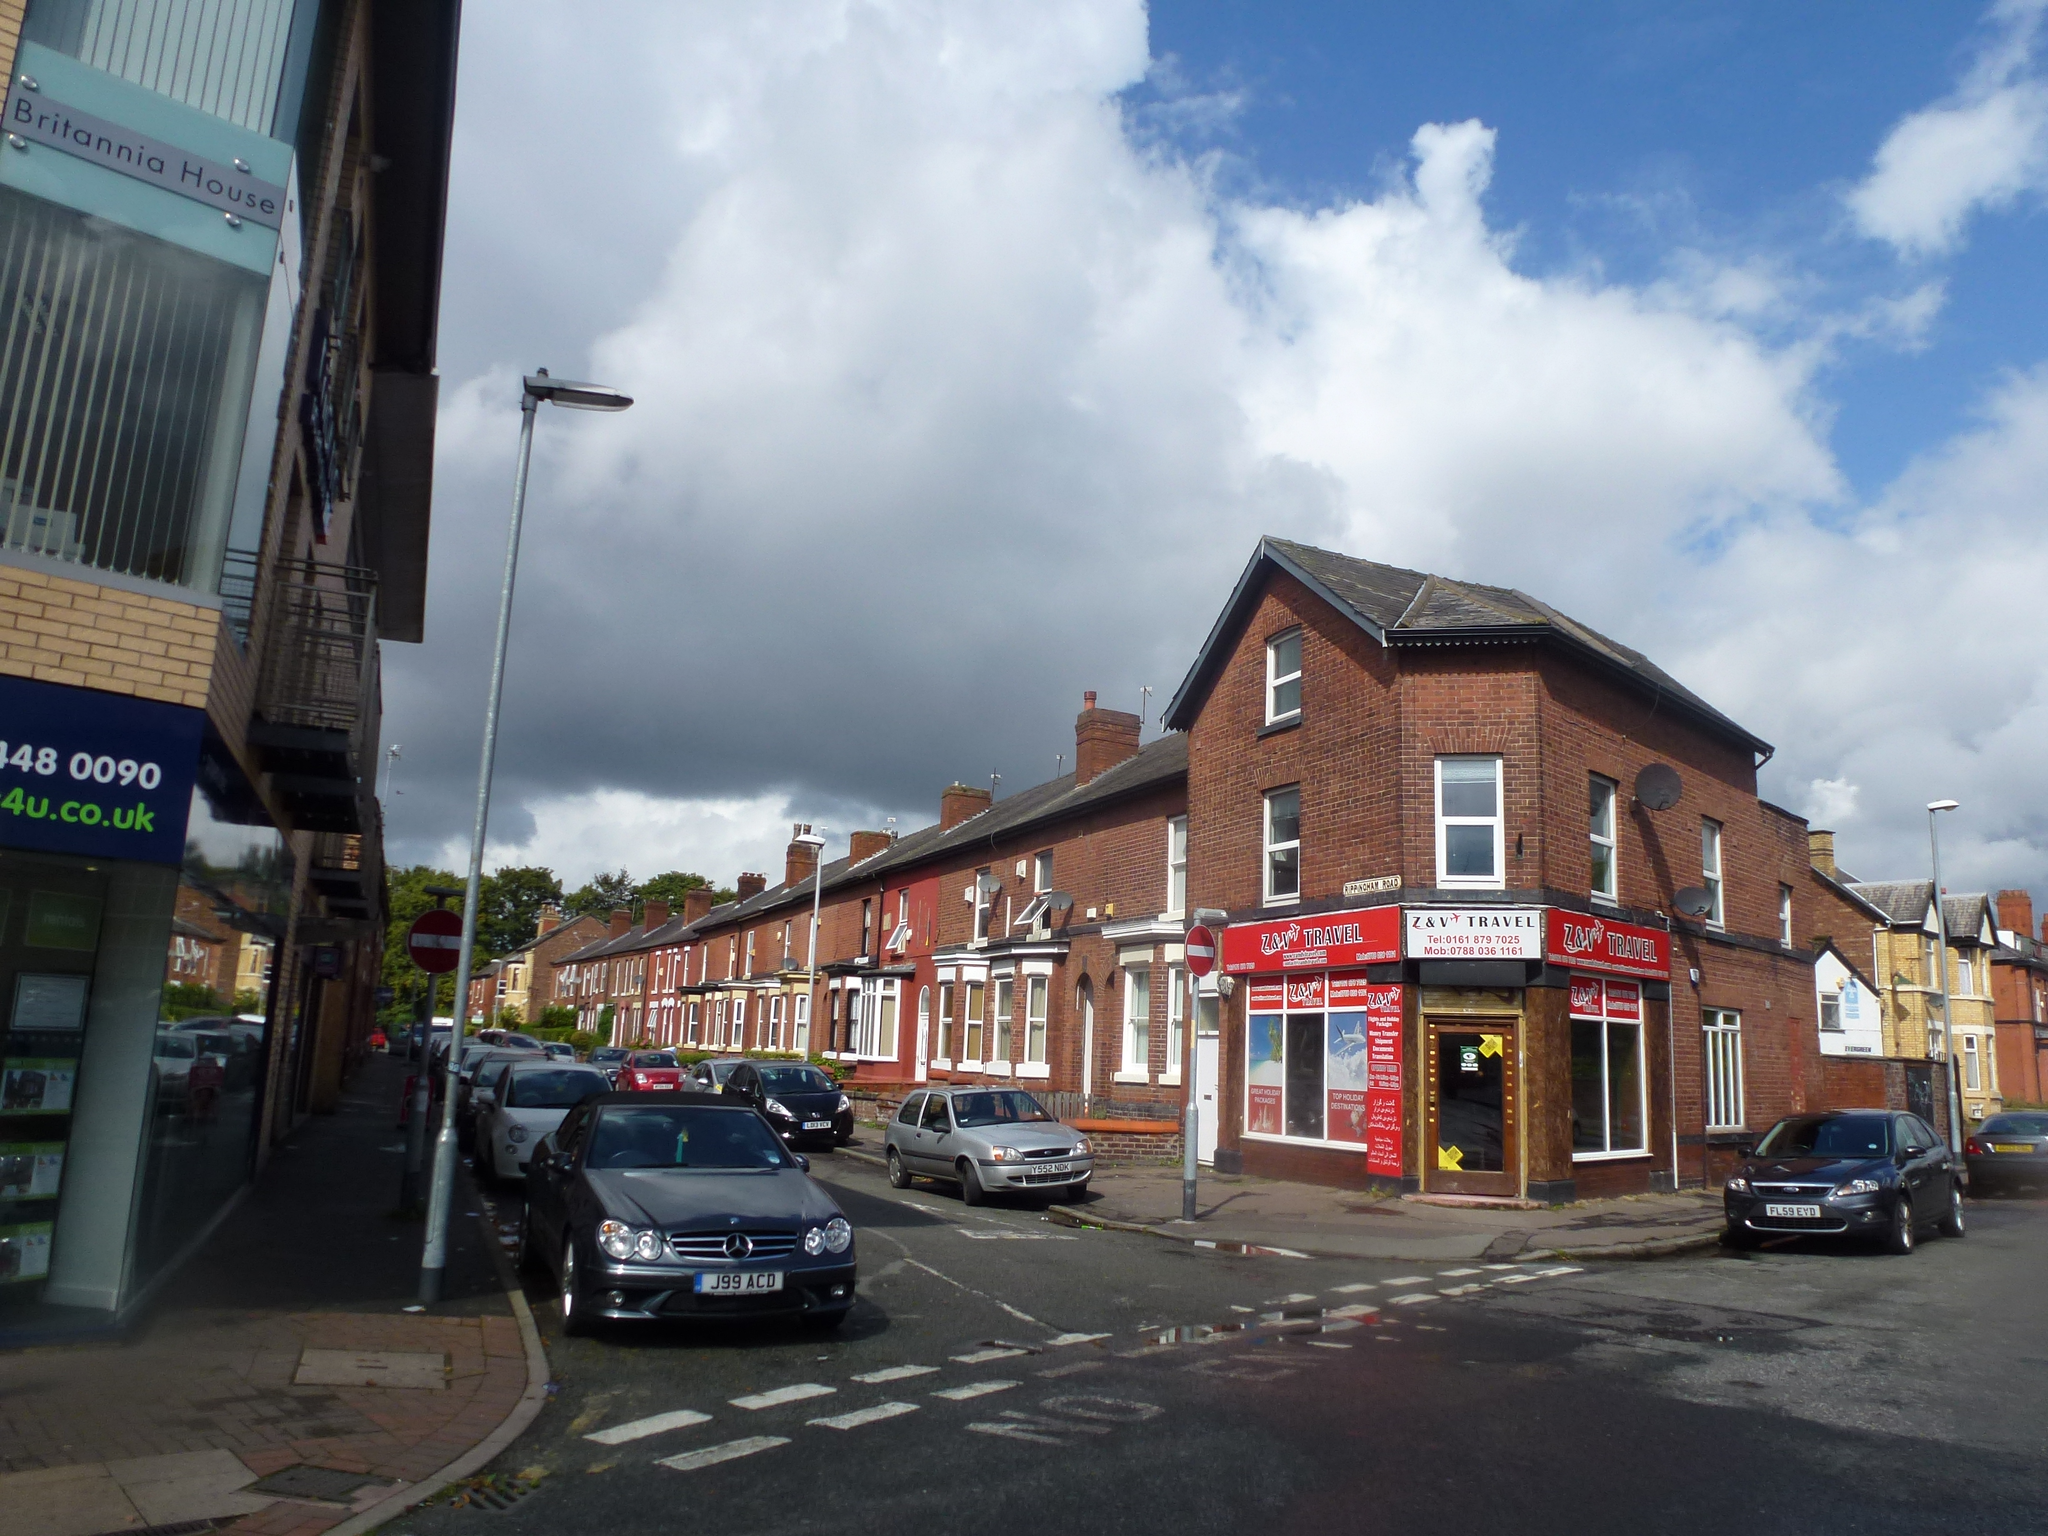Can you describe this image briefly? In this image I can see the road, few vehicles on the road, the sidewalk, few poles, few boards and few buildings on both sides of the road. In the background I can see few trees and the sky. 